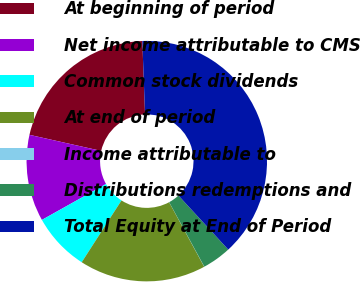Convert chart to OTSL. <chart><loc_0><loc_0><loc_500><loc_500><pie_chart><fcel>At beginning of period<fcel>Net income attributable to CMS<fcel>Common stock dividends<fcel>At end of period<fcel>Income attributable to<fcel>Distributions redemptions and<fcel>Total Equity at End of Period<nl><fcel>20.9%<fcel>11.64%<fcel>7.77%<fcel>17.03%<fcel>0.02%<fcel>3.9%<fcel>38.75%<nl></chart> 